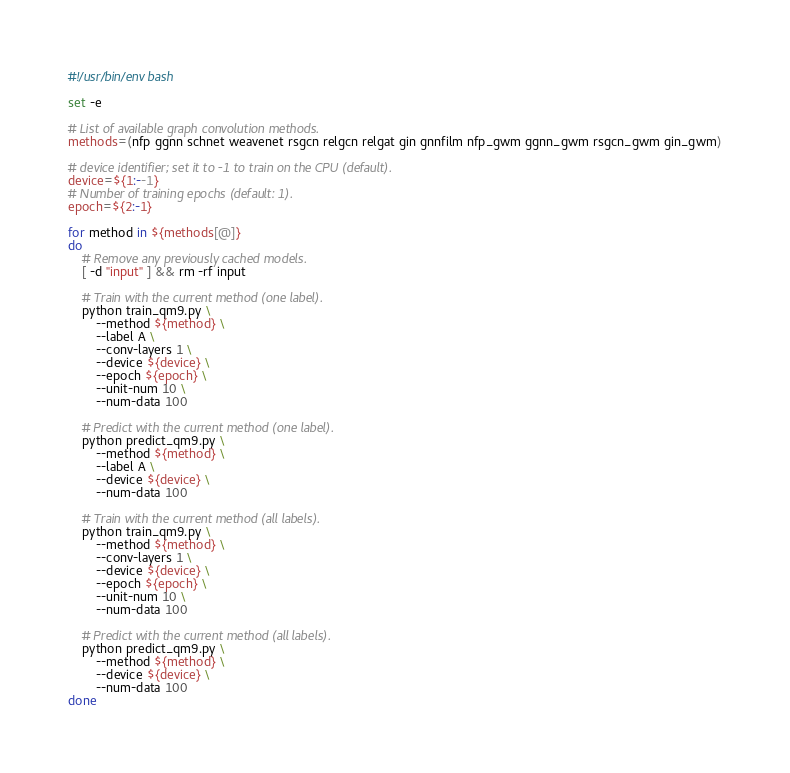<code> <loc_0><loc_0><loc_500><loc_500><_Bash_>#!/usr/bin/env bash

set -e

# List of available graph convolution methods.
methods=(nfp ggnn schnet weavenet rsgcn relgcn relgat gin gnnfilm nfp_gwm ggnn_gwm rsgcn_gwm gin_gwm)

# device identifier; set it to -1 to train on the CPU (default).
device=${1:--1}
# Number of training epochs (default: 1).
epoch=${2:-1}

for method in ${methods[@]}
do
    # Remove any previously cached models.
    [ -d "input" ] && rm -rf input

    # Train with the current method (one label).
    python train_qm9.py \
        --method ${method} \
        --label A \
        --conv-layers 1 \
        --device ${device} \
        --epoch ${epoch} \
        --unit-num 10 \
        --num-data 100

    # Predict with the current method (one label).
    python predict_qm9.py \
        --method ${method} \
        --label A \
        --device ${device} \
        --num-data 100

    # Train with the current method (all labels).
    python train_qm9.py \
        --method ${method} \
        --conv-layers 1 \
        --device ${device} \
        --epoch ${epoch} \
        --unit-num 10 \
        --num-data 100

    # Predict with the current method (all labels).
    python predict_qm9.py \
        --method ${method} \
        --device ${device} \
        --num-data 100
done
</code> 